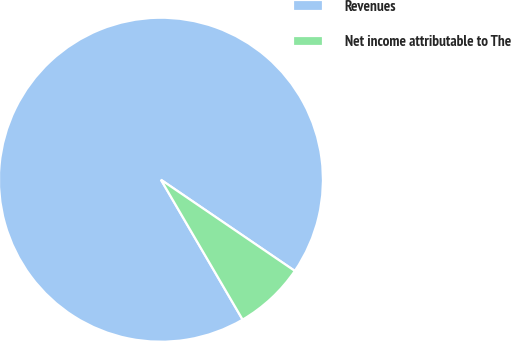<chart> <loc_0><loc_0><loc_500><loc_500><pie_chart><fcel>Revenues<fcel>Net income attributable to The<nl><fcel>92.93%<fcel>7.07%<nl></chart> 